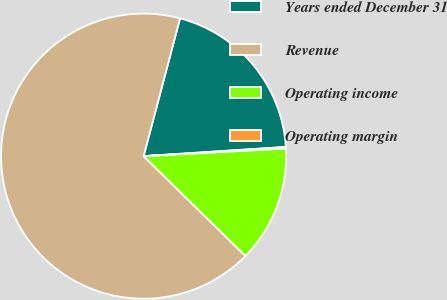Convert chart. <chart><loc_0><loc_0><loc_500><loc_500><pie_chart><fcel>Years ended December 31<fcel>Revenue<fcel>Operating income<fcel>Operating margin<nl><fcel>19.86%<fcel>66.77%<fcel>13.2%<fcel>0.17%<nl></chart> 